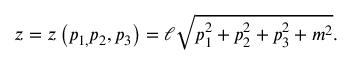Convert formula to latex. <formula><loc_0><loc_0><loc_500><loc_500>z = z \left ( p _ { 1 , } p _ { 2 } , p _ { 3 } \right ) = \ell \sqrt { p _ { 1 } ^ { 2 } + p _ { 2 } ^ { 2 } + p _ { 3 } ^ { 2 } + m ^ { 2 } } .</formula> 